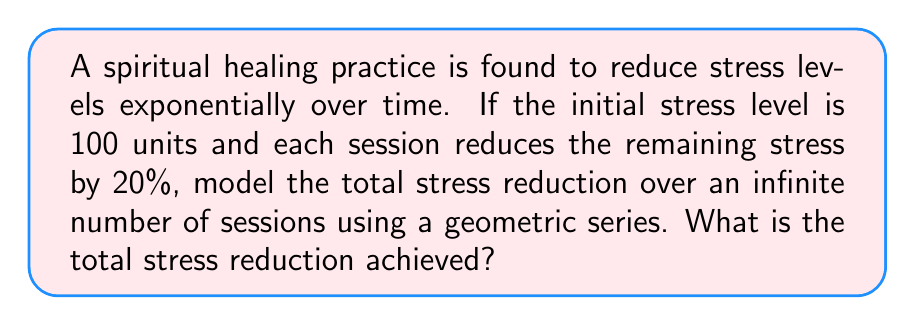Show me your answer to this math problem. Let's approach this step-by-step:

1) The initial stress level is 100 units.

2) Each session reduces the remaining stress by 20%, which means 80% of the stress remains after each session.

3) We can model this as a geometric series:

   $$S_{\infty} = a + ar + ar^2 + ar^3 + ...$$

   Where:
   $a$ = first term (initial stress reduction)
   $r$ = common ratio (fraction of stress remaining after each session)

4) Calculate $a$:
   First session reduces stress by 20% of 100: $a = 100 * 0.20 = 20$

5) Calculate $r$:
   $r = 0.80$ (80% of stress remains after each session)

6) For an infinite geometric series with $|r| < 1$, the sum is given by:

   $$S_{\infty} = \frac{a}{1-r}$$

7) Substituting our values:

   $$S_{\infty} = \frac{20}{1-0.80} = \frac{20}{0.20} = 100$$

Therefore, the total stress reduction over an infinite number of sessions is 100 units.
Answer: 100 units 